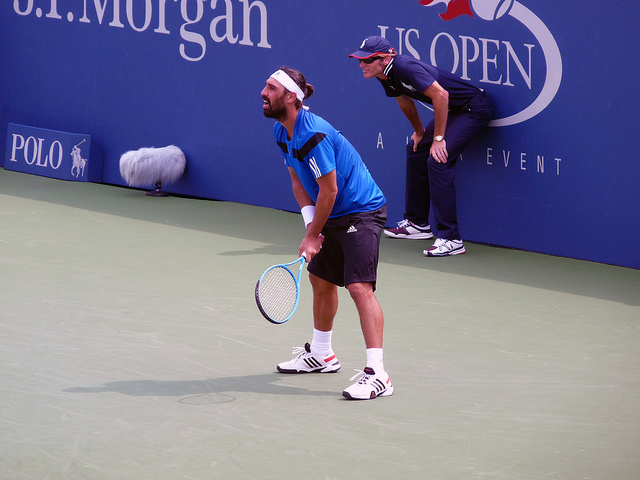<image>What is the brand on the right? I am not sure. It can be seen 'polo', 'us open' or 'jp morgan'. What is the brand on the right? I don't know the brand on the right. It could be 'polo', 'jp morgan' or 'us open'. 